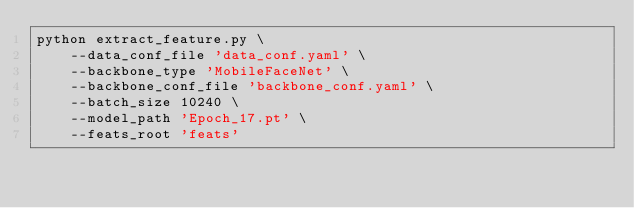<code> <loc_0><loc_0><loc_500><loc_500><_Bash_>python extract_feature.py \
    --data_conf_file 'data_conf.yaml' \
    --backbone_type 'MobileFaceNet' \
    --backbone_conf_file 'backbone_conf.yaml' \
    --batch_size 10240 \
    --model_path 'Epoch_17.pt' \
    --feats_root 'feats' 
</code> 